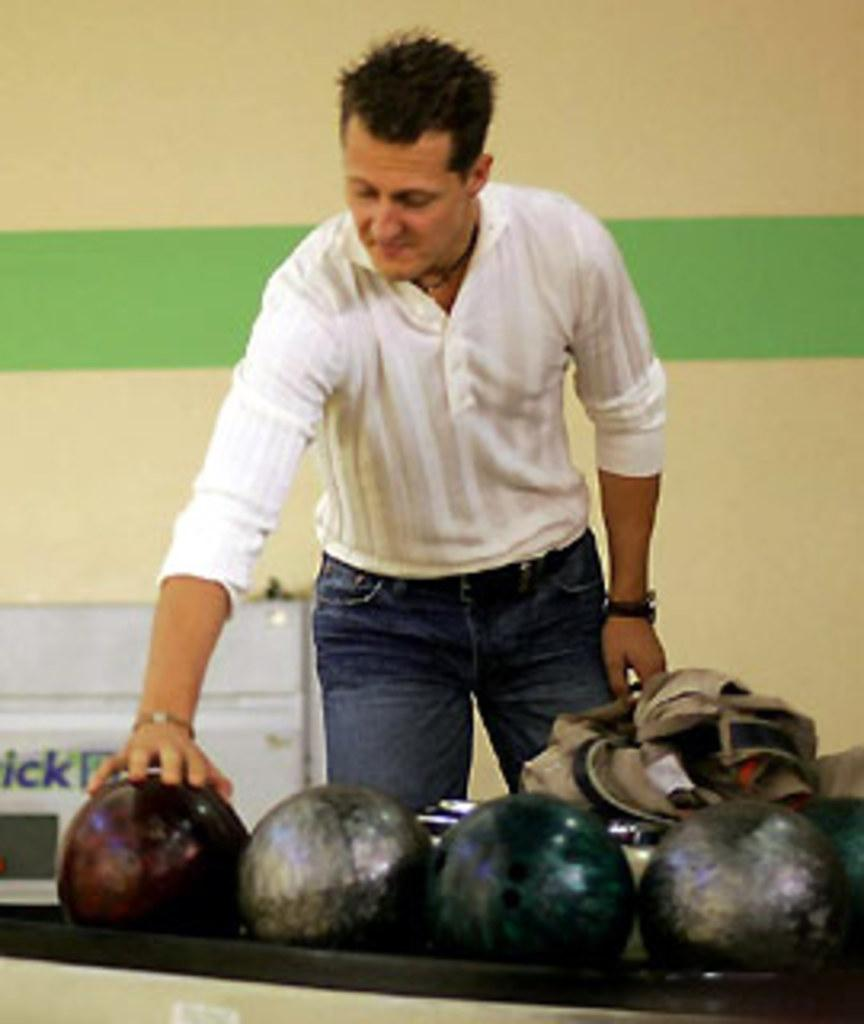What is the main subject of the image? There is a person in the image. What is the person wearing? The person is wearing a white shirt. What is the person doing in the image? The person is standing and has placed their hand on a ball. How many balls are visible in the image? There are other balls beside the ball the person is touching. What type of sound can be heard coming from the dinosaurs in the image? There are no dinosaurs present in the image, so no sound can be heard from them. 